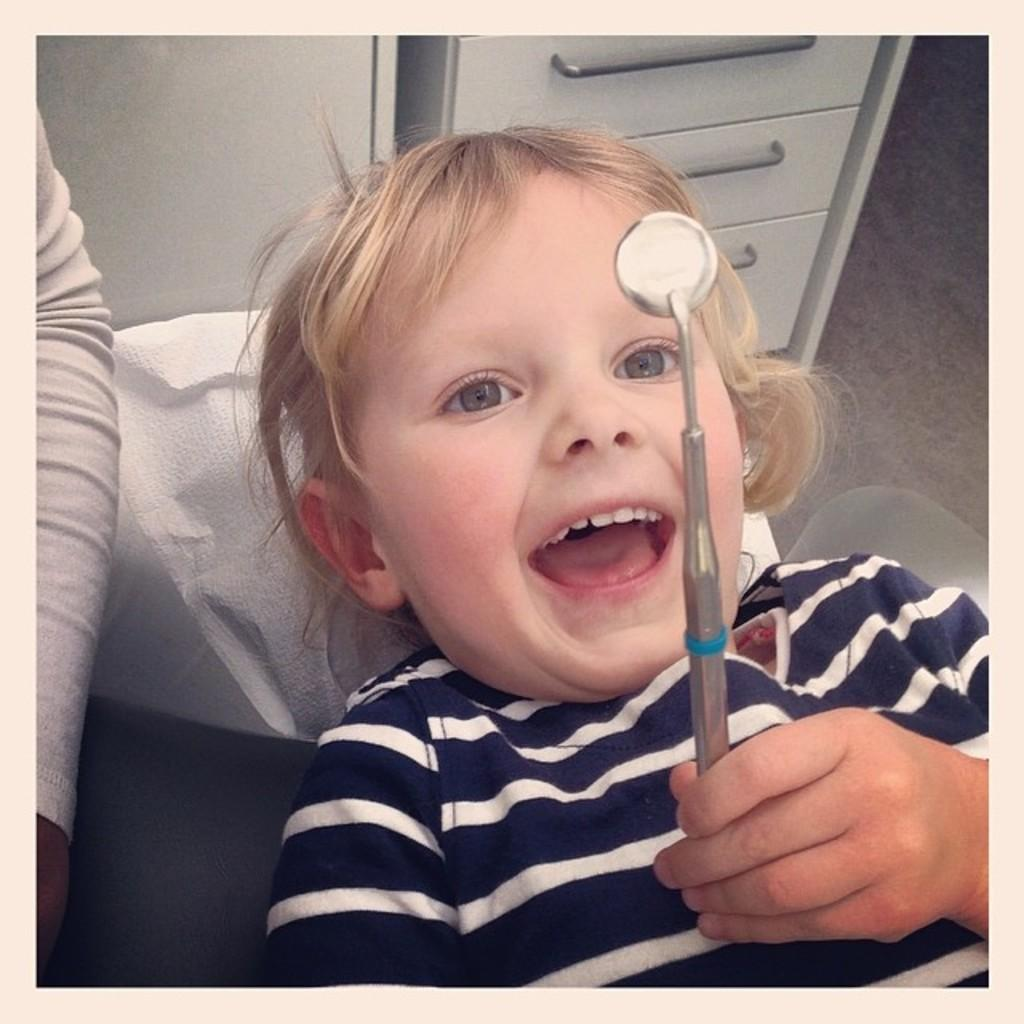How many people are in the image? There are two people in the image. What colors are the dresses of the two people? One person is wearing a white dress, and the other person is wearing a navy blue dress. What is one person holding in the image? One person is holding an object. What can be seen in the background of the image? There is a cupboard in the background of the image. What type of heart-shaped object can be seen in the image? There is no heart-shaped object present in the image. 